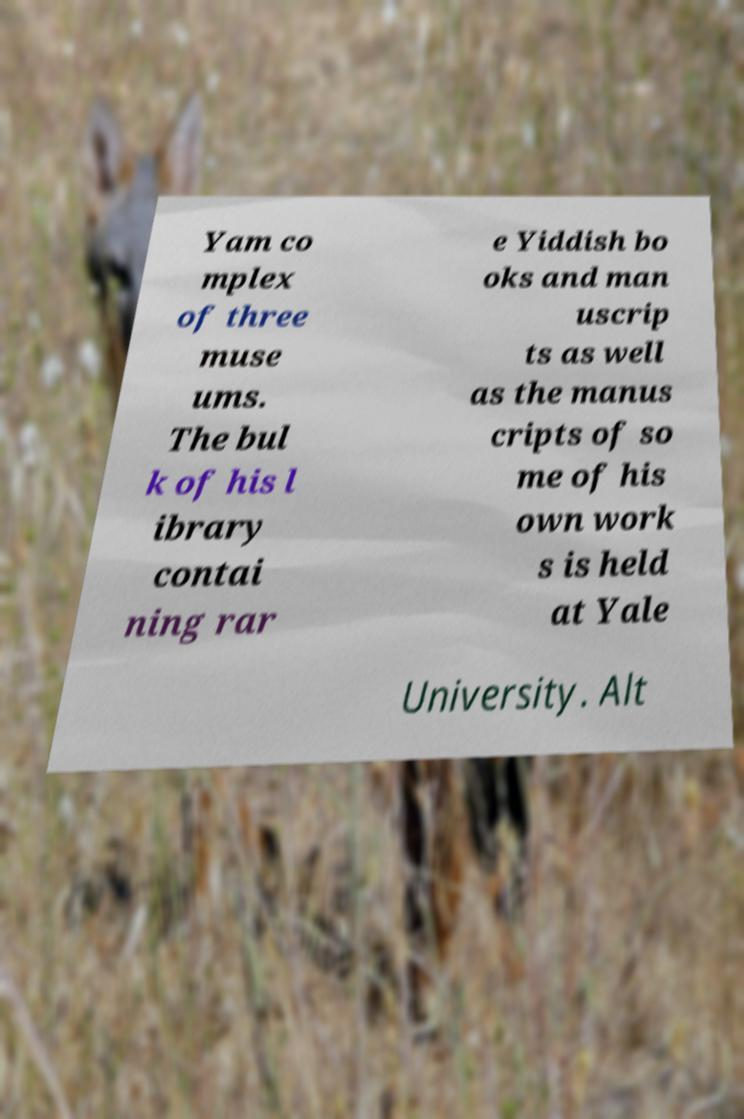Please identify and transcribe the text found in this image. Yam co mplex of three muse ums. The bul k of his l ibrary contai ning rar e Yiddish bo oks and man uscrip ts as well as the manus cripts of so me of his own work s is held at Yale University. Alt 